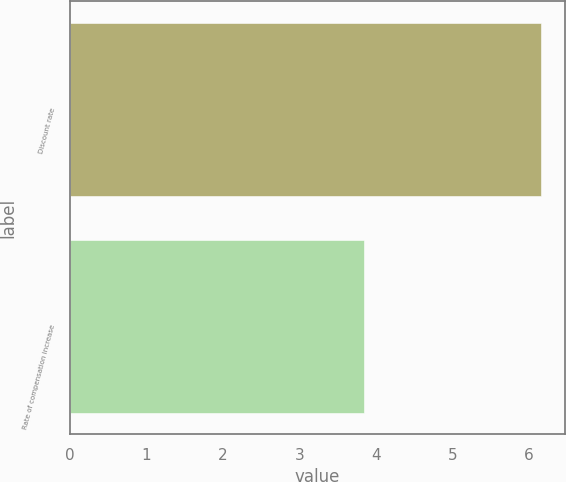Convert chart. <chart><loc_0><loc_0><loc_500><loc_500><bar_chart><fcel>Discount rate<fcel>Rate of compensation increase<nl><fcel>6.16<fcel>3.84<nl></chart> 